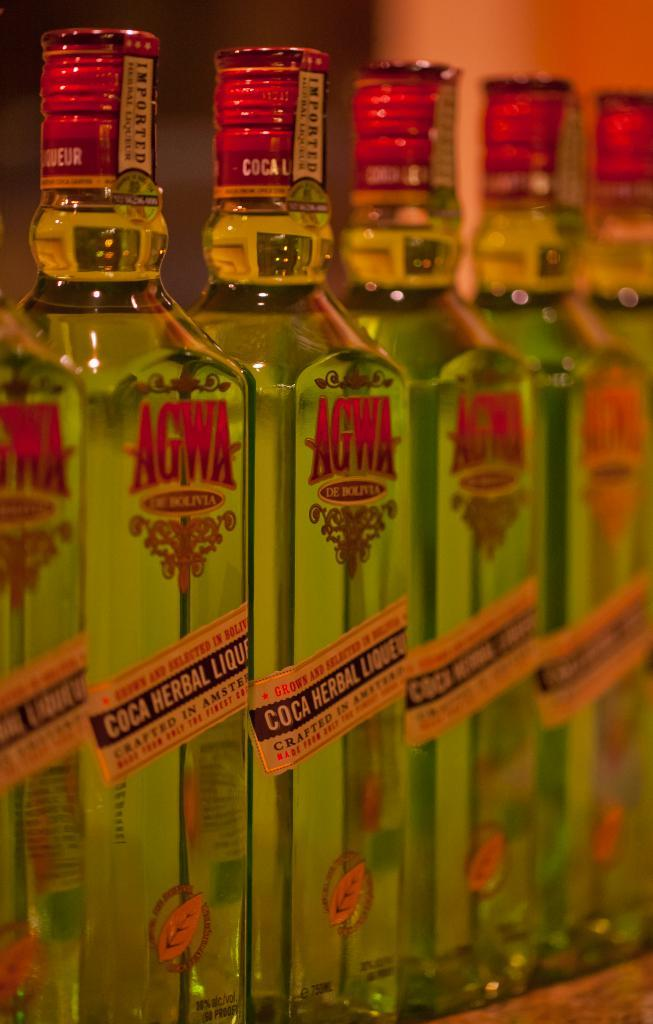<image>
Write a terse but informative summary of the picture. A full row of Agwa brand Coca Herbal Liqueur bottles. 